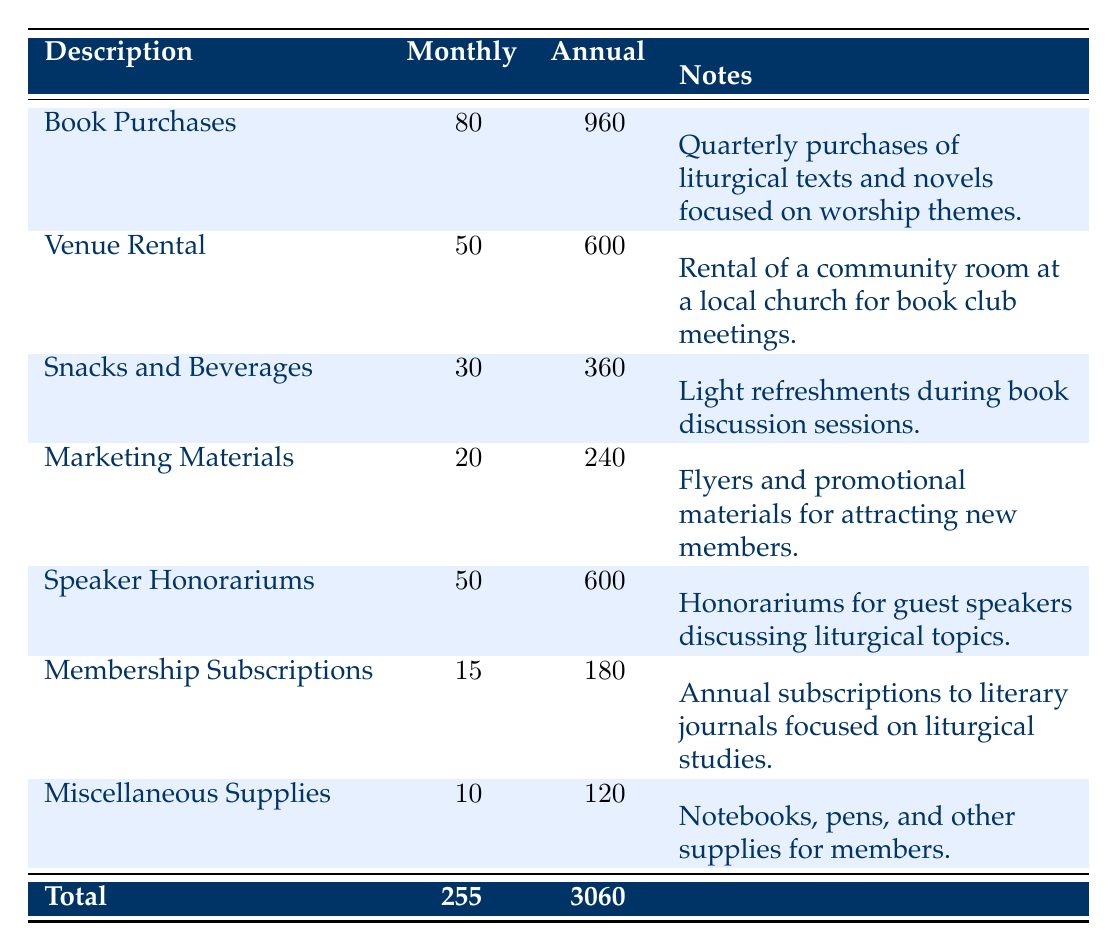What is the total annual cost for the book purchases? From the table, the annual cost for book purchases is directly stated as 960.
Answer: 960 What is the monthly expense for snacks and beverages? The monthly expense for snacks and beverages is provided in the table as 30.
Answer: 30 Is the rental cost for the venue higher than the cost for snacks and beverages? The rental cost for the venue is 50 while the cost for snacks and beverages is 30. Since 50 is greater than 30, the statement is true.
Answer: Yes What is the total annual cost of all expenses combined? To find the total annual cost, add the annual costs of all items listed: 960 + 600 + 360 + 240 + 600 + 180 + 120 = 3060. Thus, the total cost is 3060.
Answer: 3060 What is the average monthly expense for all items listed in the table? The total monthly expenses are 255 (sum of all monthly costs). There are 7 expense items, so the average monthly expense is 255 / 7 = 36.43.
Answer: 36.43 Are the marketing materials the least expensive item on a monthly basis? The marketing materials cost 20 per month, while the miscellaneous supplies cost 10 per month, which is less than 20. Hence, the marketing materials are not the least expensive.
Answer: No If the speaker honorariums were eliminated, what would be the new total monthly expense? The monthly expense without speaker honorariums (50) would be 255 - 50 = 205.
Answer: 205 Which item has the highest total cost over the year? From the table, book purchases have the highest total cost at 960.
Answer: 960 What percentage of the total monthly expense is allocated to venue rental? The venue rental is 50. To calculate the percentage of total monthly expense, (50 / 255) * 100 = 19.61%.
Answer: 19.61% 